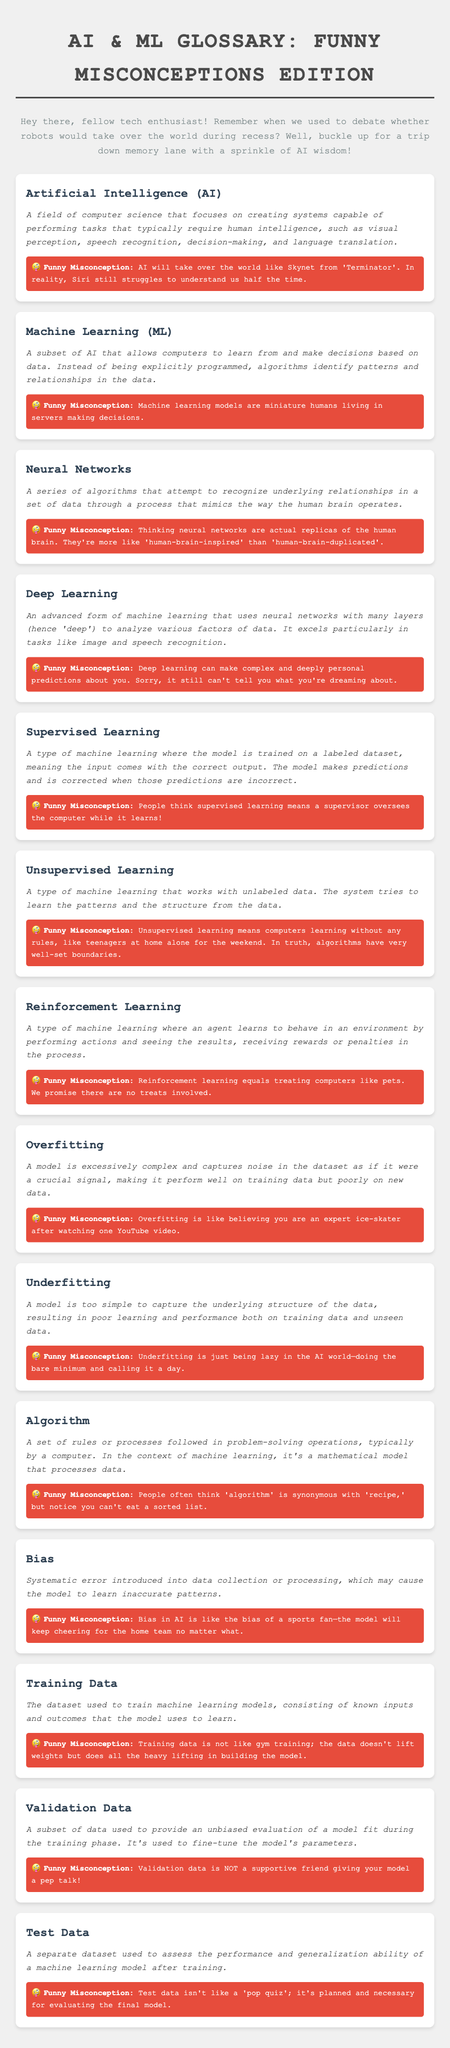what is the title of the document? The title is found in the header section of the document.
Answer: AI & ML Glossary: Funny Misconceptions Edition how many terms are listed in the glossary? By counting the number of glossary items, we find there are 15 terms.
Answer: 15 what does AI stand for? The abbreviation for Artificial Intelligence is clearly stated in the definition section.
Answer: Artificial Intelligence what is a funny misconception about Neural Networks? Misconceptions are provided under each term; for Neural Networks, it mentions that they aren't actual replicas of the human brain.
Answer: Thinking neural networks are actual replicas of the human brain what type of learning involves an agent receiving rewards or penalties? The definition helps identify this learning strategy among the various types presented.
Answer: Reinforcement Learning what is the primary purpose of Training Data? The document provides a definition explaining the role of Training Data in machine learning.
Answer: To train machine learning models how is Underfitting humorously described? The definition provides a humorous take on Underfitting within the context of AI.
Answer: Just being lazy in the AI world what does the term "Validation Data" refer to? Its definition explicitly states its function in evaluating a model during training.
Answer: A subset of data used for evaluation what systematic issue does the term Bias refer to? The definition clarifies the type of error introduced into data collection or processing.
Answer: Systematic error what is the misconception about algorithms compared to recipes? The misconception section presents this humorously, comparing algorithms and recipes.
Answer: People often think 'algorithm' is synonymous with 'recipe' 